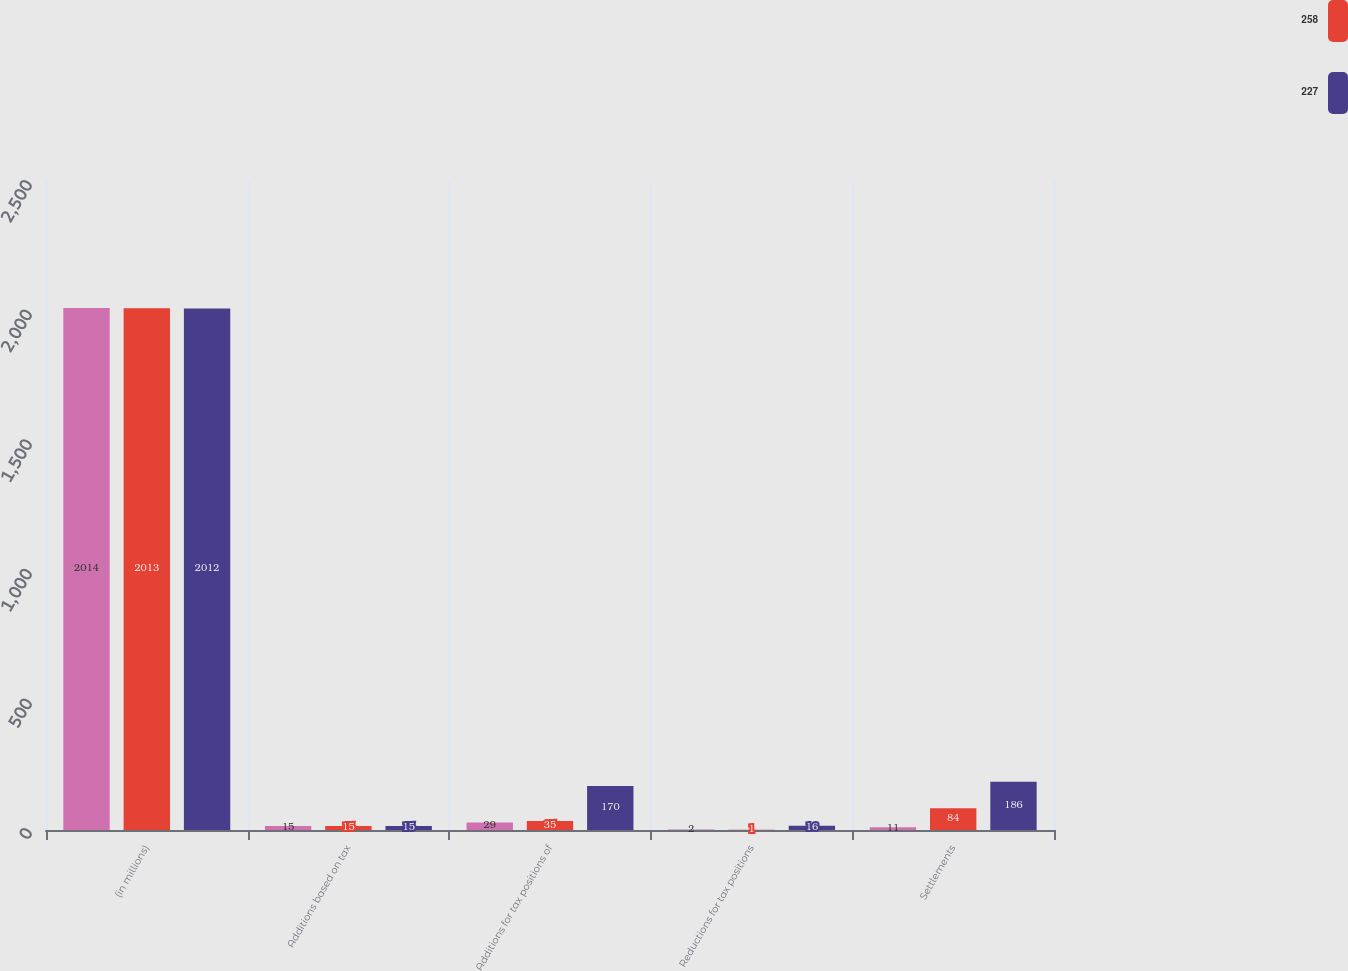Convert chart to OTSL. <chart><loc_0><loc_0><loc_500><loc_500><stacked_bar_chart><ecel><fcel>(in millions)<fcel>Additions based on tax<fcel>Additions for tax positions of<fcel>Reductions for tax positions<fcel>Settlements<nl><fcel>nan<fcel>2014<fcel>15<fcel>29<fcel>2<fcel>11<nl><fcel>258<fcel>2013<fcel>15<fcel>35<fcel>1<fcel>84<nl><fcel>227<fcel>2012<fcel>15<fcel>170<fcel>16<fcel>186<nl></chart> 